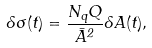Convert formula to latex. <formula><loc_0><loc_0><loc_500><loc_500>\delta \sigma ( t ) = \frac { N _ { q } Q } { \bar { A } ^ { 2 } } \delta A ( t ) ,</formula> 